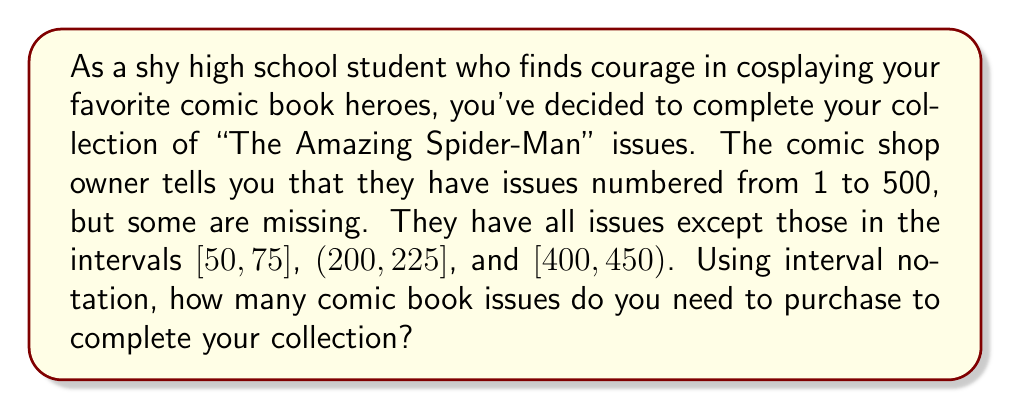Can you solve this math problem? Let's approach this step-by-step:

1) First, we need to understand what the intervals mean:
   - $[50, 75]$ means issues 50 to 75, including both 50 and 75
   - $(200, 225]$ means issues 201 to 225, including 225
   - $[400, 450)$ means issues 400 to 449, including 400 but not 450

2) Now, let's calculate the number of issues in each interval:
   - $[50, 75]$: $75 - 50 + 1 = 26$ issues
   - $(200, 225]$: $225 - 200 = 25$ issues
   - $[400, 450)$: $450 - 400 = 50$ issues

3) To find the total number of issues needed, we sum these up:
   $26 + 25 + 50 = 101$ issues

4) We can express this answer in interval notation as follows:
   $[50, 75] \cup (200, 225] \cup [400, 450)$

This notation indicates that you need to purchase all issues within these intervals to complete your collection.
Answer: 101 issues, represented in interval notation as $[50, 75] \cup (200, 225] \cup [400, 450)$ 